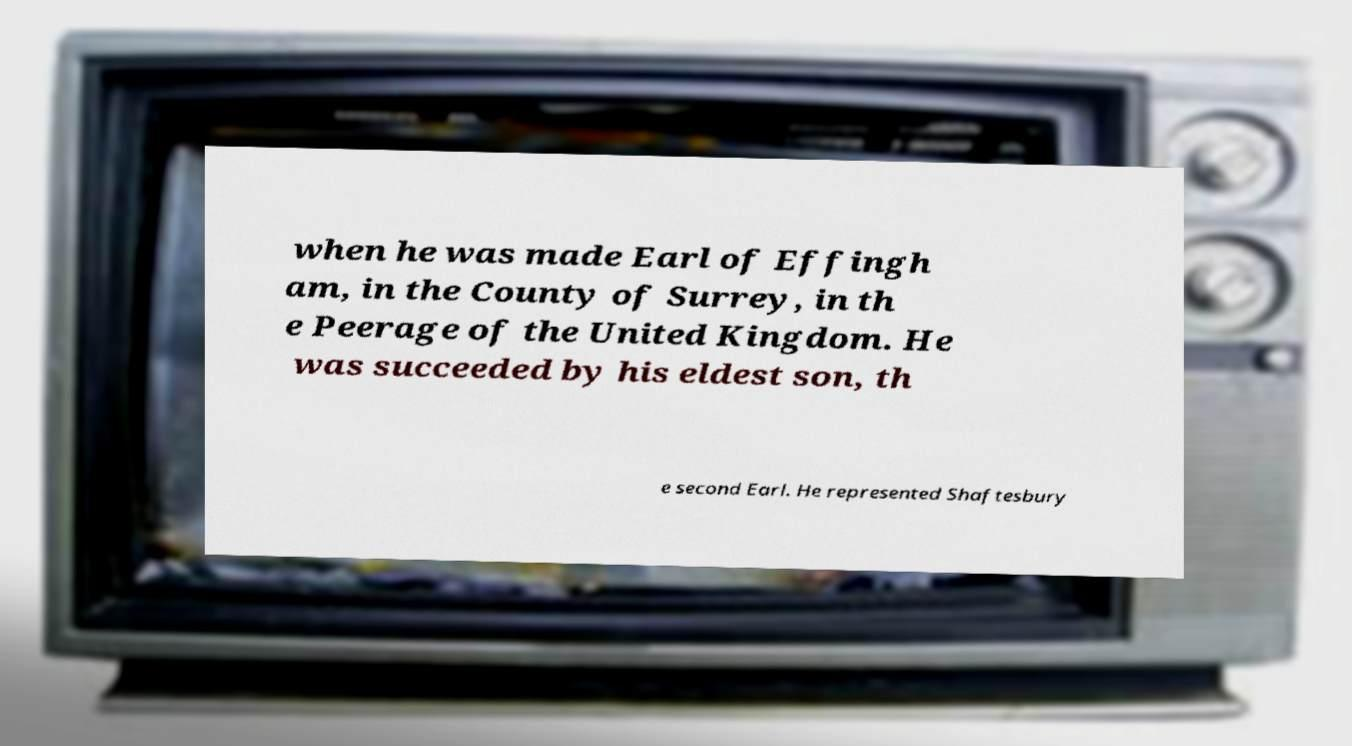Please read and relay the text visible in this image. What does it say? when he was made Earl of Effingh am, in the County of Surrey, in th e Peerage of the United Kingdom. He was succeeded by his eldest son, th e second Earl. He represented Shaftesbury 